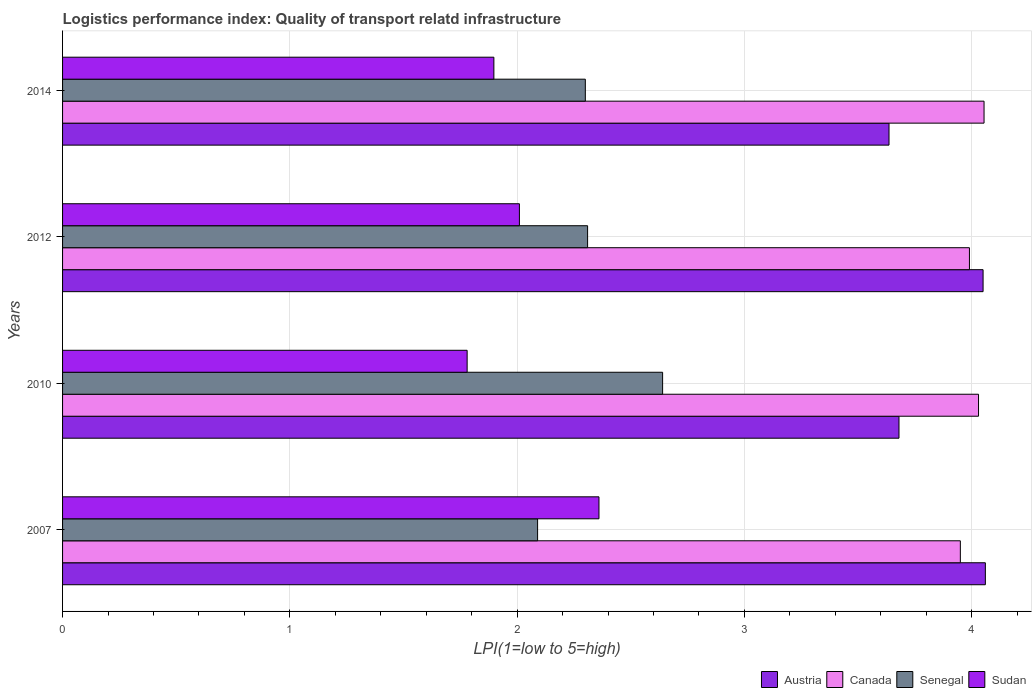How many different coloured bars are there?
Ensure brevity in your answer.  4. Are the number of bars per tick equal to the number of legend labels?
Provide a succinct answer. Yes. How many bars are there on the 4th tick from the top?
Keep it short and to the point. 4. How many bars are there on the 4th tick from the bottom?
Make the answer very short. 4. What is the logistics performance index in Canada in 2012?
Offer a very short reply. 3.99. Across all years, what is the maximum logistics performance index in Senegal?
Make the answer very short. 2.64. Across all years, what is the minimum logistics performance index in Austria?
Provide a short and direct response. 3.64. In which year was the logistics performance index in Austria minimum?
Your answer should be compact. 2014. What is the total logistics performance index in Canada in the graph?
Provide a succinct answer. 16.02. What is the difference between the logistics performance index in Canada in 2010 and that in 2014?
Make the answer very short. -0.02. What is the difference between the logistics performance index in Senegal in 2014 and the logistics performance index in Canada in 2007?
Ensure brevity in your answer.  -1.65. What is the average logistics performance index in Austria per year?
Your answer should be compact. 3.86. In the year 2007, what is the difference between the logistics performance index in Canada and logistics performance index in Senegal?
Offer a terse response. 1.86. In how many years, is the logistics performance index in Canada greater than 2.6 ?
Your answer should be compact. 4. What is the ratio of the logistics performance index in Sudan in 2007 to that in 2014?
Your response must be concise. 1.24. What is the difference between the highest and the second highest logistics performance index in Sudan?
Ensure brevity in your answer.  0.35. What is the difference between the highest and the lowest logistics performance index in Sudan?
Provide a succinct answer. 0.58. In how many years, is the logistics performance index in Sudan greater than the average logistics performance index in Sudan taken over all years?
Offer a very short reply. 1. Is the sum of the logistics performance index in Austria in 2007 and 2014 greater than the maximum logistics performance index in Sudan across all years?
Ensure brevity in your answer.  Yes. Is it the case that in every year, the sum of the logistics performance index in Senegal and logistics performance index in Canada is greater than the sum of logistics performance index in Sudan and logistics performance index in Austria?
Your answer should be very brief. Yes. What does the 2nd bar from the top in 2014 represents?
Ensure brevity in your answer.  Senegal. Is it the case that in every year, the sum of the logistics performance index in Austria and logistics performance index in Canada is greater than the logistics performance index in Senegal?
Make the answer very short. Yes. What is the difference between two consecutive major ticks on the X-axis?
Provide a succinct answer. 1. Does the graph contain grids?
Your answer should be very brief. Yes. How many legend labels are there?
Provide a short and direct response. 4. What is the title of the graph?
Your answer should be very brief. Logistics performance index: Quality of transport relatd infrastructure. Does "Pacific island small states" appear as one of the legend labels in the graph?
Your answer should be very brief. No. What is the label or title of the X-axis?
Make the answer very short. LPI(1=low to 5=high). What is the label or title of the Y-axis?
Make the answer very short. Years. What is the LPI(1=low to 5=high) of Austria in 2007?
Make the answer very short. 4.06. What is the LPI(1=low to 5=high) of Canada in 2007?
Offer a terse response. 3.95. What is the LPI(1=low to 5=high) of Senegal in 2007?
Offer a very short reply. 2.09. What is the LPI(1=low to 5=high) in Sudan in 2007?
Provide a succinct answer. 2.36. What is the LPI(1=low to 5=high) of Austria in 2010?
Your answer should be compact. 3.68. What is the LPI(1=low to 5=high) in Canada in 2010?
Your response must be concise. 4.03. What is the LPI(1=low to 5=high) in Senegal in 2010?
Keep it short and to the point. 2.64. What is the LPI(1=low to 5=high) of Sudan in 2010?
Keep it short and to the point. 1.78. What is the LPI(1=low to 5=high) in Austria in 2012?
Offer a terse response. 4.05. What is the LPI(1=low to 5=high) in Canada in 2012?
Make the answer very short. 3.99. What is the LPI(1=low to 5=high) in Senegal in 2012?
Ensure brevity in your answer.  2.31. What is the LPI(1=low to 5=high) of Sudan in 2012?
Provide a succinct answer. 2.01. What is the LPI(1=low to 5=high) of Austria in 2014?
Keep it short and to the point. 3.64. What is the LPI(1=low to 5=high) of Canada in 2014?
Your response must be concise. 4.05. What is the LPI(1=low to 5=high) of Sudan in 2014?
Make the answer very short. 1.9. Across all years, what is the maximum LPI(1=low to 5=high) of Austria?
Offer a terse response. 4.06. Across all years, what is the maximum LPI(1=low to 5=high) of Canada?
Your response must be concise. 4.05. Across all years, what is the maximum LPI(1=low to 5=high) of Senegal?
Your response must be concise. 2.64. Across all years, what is the maximum LPI(1=low to 5=high) in Sudan?
Your answer should be very brief. 2.36. Across all years, what is the minimum LPI(1=low to 5=high) of Austria?
Your answer should be compact. 3.64. Across all years, what is the minimum LPI(1=low to 5=high) in Canada?
Your answer should be very brief. 3.95. Across all years, what is the minimum LPI(1=low to 5=high) of Senegal?
Your response must be concise. 2.09. Across all years, what is the minimum LPI(1=low to 5=high) in Sudan?
Provide a succinct answer. 1.78. What is the total LPI(1=low to 5=high) of Austria in the graph?
Your answer should be compact. 15.43. What is the total LPI(1=low to 5=high) in Canada in the graph?
Provide a short and direct response. 16.02. What is the total LPI(1=low to 5=high) in Senegal in the graph?
Provide a succinct answer. 9.34. What is the total LPI(1=low to 5=high) in Sudan in the graph?
Provide a short and direct response. 8.05. What is the difference between the LPI(1=low to 5=high) of Austria in 2007 and that in 2010?
Ensure brevity in your answer.  0.38. What is the difference between the LPI(1=low to 5=high) of Canada in 2007 and that in 2010?
Offer a terse response. -0.08. What is the difference between the LPI(1=low to 5=high) in Senegal in 2007 and that in 2010?
Offer a terse response. -0.55. What is the difference between the LPI(1=low to 5=high) in Sudan in 2007 and that in 2010?
Provide a short and direct response. 0.58. What is the difference between the LPI(1=low to 5=high) in Austria in 2007 and that in 2012?
Your response must be concise. 0.01. What is the difference between the LPI(1=low to 5=high) of Canada in 2007 and that in 2012?
Your response must be concise. -0.04. What is the difference between the LPI(1=low to 5=high) in Senegal in 2007 and that in 2012?
Ensure brevity in your answer.  -0.22. What is the difference between the LPI(1=low to 5=high) of Sudan in 2007 and that in 2012?
Give a very brief answer. 0.35. What is the difference between the LPI(1=low to 5=high) in Austria in 2007 and that in 2014?
Keep it short and to the point. 0.42. What is the difference between the LPI(1=low to 5=high) in Canada in 2007 and that in 2014?
Provide a short and direct response. -0.1. What is the difference between the LPI(1=low to 5=high) of Senegal in 2007 and that in 2014?
Provide a short and direct response. -0.21. What is the difference between the LPI(1=low to 5=high) of Sudan in 2007 and that in 2014?
Ensure brevity in your answer.  0.46. What is the difference between the LPI(1=low to 5=high) of Austria in 2010 and that in 2012?
Provide a succinct answer. -0.37. What is the difference between the LPI(1=low to 5=high) of Canada in 2010 and that in 2012?
Keep it short and to the point. 0.04. What is the difference between the LPI(1=low to 5=high) in Senegal in 2010 and that in 2012?
Provide a succinct answer. 0.33. What is the difference between the LPI(1=low to 5=high) of Sudan in 2010 and that in 2012?
Your answer should be very brief. -0.23. What is the difference between the LPI(1=low to 5=high) in Austria in 2010 and that in 2014?
Give a very brief answer. 0.04. What is the difference between the LPI(1=low to 5=high) of Canada in 2010 and that in 2014?
Ensure brevity in your answer.  -0.02. What is the difference between the LPI(1=low to 5=high) of Senegal in 2010 and that in 2014?
Offer a very short reply. 0.34. What is the difference between the LPI(1=low to 5=high) in Sudan in 2010 and that in 2014?
Provide a succinct answer. -0.12. What is the difference between the LPI(1=low to 5=high) in Austria in 2012 and that in 2014?
Provide a succinct answer. 0.41. What is the difference between the LPI(1=low to 5=high) of Canada in 2012 and that in 2014?
Your response must be concise. -0.06. What is the difference between the LPI(1=low to 5=high) of Senegal in 2012 and that in 2014?
Offer a terse response. 0.01. What is the difference between the LPI(1=low to 5=high) in Sudan in 2012 and that in 2014?
Keep it short and to the point. 0.11. What is the difference between the LPI(1=low to 5=high) of Austria in 2007 and the LPI(1=low to 5=high) of Senegal in 2010?
Provide a short and direct response. 1.42. What is the difference between the LPI(1=low to 5=high) of Austria in 2007 and the LPI(1=low to 5=high) of Sudan in 2010?
Provide a succinct answer. 2.28. What is the difference between the LPI(1=low to 5=high) of Canada in 2007 and the LPI(1=low to 5=high) of Senegal in 2010?
Ensure brevity in your answer.  1.31. What is the difference between the LPI(1=low to 5=high) of Canada in 2007 and the LPI(1=low to 5=high) of Sudan in 2010?
Your answer should be very brief. 2.17. What is the difference between the LPI(1=low to 5=high) in Senegal in 2007 and the LPI(1=low to 5=high) in Sudan in 2010?
Offer a terse response. 0.31. What is the difference between the LPI(1=low to 5=high) in Austria in 2007 and the LPI(1=low to 5=high) in Canada in 2012?
Your answer should be very brief. 0.07. What is the difference between the LPI(1=low to 5=high) of Austria in 2007 and the LPI(1=low to 5=high) of Sudan in 2012?
Make the answer very short. 2.05. What is the difference between the LPI(1=low to 5=high) in Canada in 2007 and the LPI(1=low to 5=high) in Senegal in 2012?
Provide a succinct answer. 1.64. What is the difference between the LPI(1=low to 5=high) in Canada in 2007 and the LPI(1=low to 5=high) in Sudan in 2012?
Your answer should be compact. 1.94. What is the difference between the LPI(1=low to 5=high) in Austria in 2007 and the LPI(1=low to 5=high) in Canada in 2014?
Give a very brief answer. 0.01. What is the difference between the LPI(1=low to 5=high) in Austria in 2007 and the LPI(1=low to 5=high) in Senegal in 2014?
Your answer should be compact. 1.76. What is the difference between the LPI(1=low to 5=high) of Austria in 2007 and the LPI(1=low to 5=high) of Sudan in 2014?
Keep it short and to the point. 2.16. What is the difference between the LPI(1=low to 5=high) in Canada in 2007 and the LPI(1=low to 5=high) in Senegal in 2014?
Offer a very short reply. 1.65. What is the difference between the LPI(1=low to 5=high) in Canada in 2007 and the LPI(1=low to 5=high) in Sudan in 2014?
Give a very brief answer. 2.05. What is the difference between the LPI(1=low to 5=high) in Senegal in 2007 and the LPI(1=low to 5=high) in Sudan in 2014?
Your answer should be compact. 0.19. What is the difference between the LPI(1=low to 5=high) of Austria in 2010 and the LPI(1=low to 5=high) of Canada in 2012?
Ensure brevity in your answer.  -0.31. What is the difference between the LPI(1=low to 5=high) of Austria in 2010 and the LPI(1=low to 5=high) of Senegal in 2012?
Ensure brevity in your answer.  1.37. What is the difference between the LPI(1=low to 5=high) of Austria in 2010 and the LPI(1=low to 5=high) of Sudan in 2012?
Make the answer very short. 1.67. What is the difference between the LPI(1=low to 5=high) of Canada in 2010 and the LPI(1=low to 5=high) of Senegal in 2012?
Keep it short and to the point. 1.72. What is the difference between the LPI(1=low to 5=high) of Canada in 2010 and the LPI(1=low to 5=high) of Sudan in 2012?
Offer a very short reply. 2.02. What is the difference between the LPI(1=low to 5=high) of Senegal in 2010 and the LPI(1=low to 5=high) of Sudan in 2012?
Give a very brief answer. 0.63. What is the difference between the LPI(1=low to 5=high) of Austria in 2010 and the LPI(1=low to 5=high) of Canada in 2014?
Make the answer very short. -0.37. What is the difference between the LPI(1=low to 5=high) of Austria in 2010 and the LPI(1=low to 5=high) of Senegal in 2014?
Offer a terse response. 1.38. What is the difference between the LPI(1=low to 5=high) of Austria in 2010 and the LPI(1=low to 5=high) of Sudan in 2014?
Keep it short and to the point. 1.78. What is the difference between the LPI(1=low to 5=high) in Canada in 2010 and the LPI(1=low to 5=high) in Senegal in 2014?
Offer a terse response. 1.73. What is the difference between the LPI(1=low to 5=high) of Canada in 2010 and the LPI(1=low to 5=high) of Sudan in 2014?
Offer a terse response. 2.13. What is the difference between the LPI(1=low to 5=high) of Senegal in 2010 and the LPI(1=low to 5=high) of Sudan in 2014?
Ensure brevity in your answer.  0.74. What is the difference between the LPI(1=low to 5=high) of Austria in 2012 and the LPI(1=low to 5=high) of Canada in 2014?
Your response must be concise. -0. What is the difference between the LPI(1=low to 5=high) in Austria in 2012 and the LPI(1=low to 5=high) in Senegal in 2014?
Your answer should be compact. 1.75. What is the difference between the LPI(1=low to 5=high) of Austria in 2012 and the LPI(1=low to 5=high) of Sudan in 2014?
Offer a terse response. 2.15. What is the difference between the LPI(1=low to 5=high) in Canada in 2012 and the LPI(1=low to 5=high) in Senegal in 2014?
Keep it short and to the point. 1.69. What is the difference between the LPI(1=low to 5=high) in Canada in 2012 and the LPI(1=low to 5=high) in Sudan in 2014?
Keep it short and to the point. 2.09. What is the difference between the LPI(1=low to 5=high) of Senegal in 2012 and the LPI(1=low to 5=high) of Sudan in 2014?
Give a very brief answer. 0.41. What is the average LPI(1=low to 5=high) in Austria per year?
Give a very brief answer. 3.86. What is the average LPI(1=low to 5=high) of Canada per year?
Offer a terse response. 4.01. What is the average LPI(1=low to 5=high) in Senegal per year?
Your answer should be very brief. 2.33. What is the average LPI(1=low to 5=high) in Sudan per year?
Give a very brief answer. 2.01. In the year 2007, what is the difference between the LPI(1=low to 5=high) in Austria and LPI(1=low to 5=high) in Canada?
Your answer should be very brief. 0.11. In the year 2007, what is the difference between the LPI(1=low to 5=high) of Austria and LPI(1=low to 5=high) of Senegal?
Provide a succinct answer. 1.97. In the year 2007, what is the difference between the LPI(1=low to 5=high) in Canada and LPI(1=low to 5=high) in Senegal?
Your answer should be compact. 1.86. In the year 2007, what is the difference between the LPI(1=low to 5=high) of Canada and LPI(1=low to 5=high) of Sudan?
Provide a succinct answer. 1.59. In the year 2007, what is the difference between the LPI(1=low to 5=high) of Senegal and LPI(1=low to 5=high) of Sudan?
Your answer should be compact. -0.27. In the year 2010, what is the difference between the LPI(1=low to 5=high) of Austria and LPI(1=low to 5=high) of Canada?
Your response must be concise. -0.35. In the year 2010, what is the difference between the LPI(1=low to 5=high) of Canada and LPI(1=low to 5=high) of Senegal?
Offer a terse response. 1.39. In the year 2010, what is the difference between the LPI(1=low to 5=high) in Canada and LPI(1=low to 5=high) in Sudan?
Provide a short and direct response. 2.25. In the year 2010, what is the difference between the LPI(1=low to 5=high) in Senegal and LPI(1=low to 5=high) in Sudan?
Offer a terse response. 0.86. In the year 2012, what is the difference between the LPI(1=low to 5=high) of Austria and LPI(1=low to 5=high) of Canada?
Ensure brevity in your answer.  0.06. In the year 2012, what is the difference between the LPI(1=low to 5=high) of Austria and LPI(1=low to 5=high) of Senegal?
Ensure brevity in your answer.  1.74. In the year 2012, what is the difference between the LPI(1=low to 5=high) in Austria and LPI(1=low to 5=high) in Sudan?
Provide a short and direct response. 2.04. In the year 2012, what is the difference between the LPI(1=low to 5=high) in Canada and LPI(1=low to 5=high) in Senegal?
Offer a terse response. 1.68. In the year 2012, what is the difference between the LPI(1=low to 5=high) of Canada and LPI(1=low to 5=high) of Sudan?
Your answer should be very brief. 1.98. In the year 2014, what is the difference between the LPI(1=low to 5=high) of Austria and LPI(1=low to 5=high) of Canada?
Provide a short and direct response. -0.42. In the year 2014, what is the difference between the LPI(1=low to 5=high) in Austria and LPI(1=low to 5=high) in Senegal?
Offer a terse response. 1.34. In the year 2014, what is the difference between the LPI(1=low to 5=high) of Austria and LPI(1=low to 5=high) of Sudan?
Your answer should be compact. 1.74. In the year 2014, what is the difference between the LPI(1=low to 5=high) of Canada and LPI(1=low to 5=high) of Senegal?
Keep it short and to the point. 1.75. In the year 2014, what is the difference between the LPI(1=low to 5=high) in Canada and LPI(1=low to 5=high) in Sudan?
Provide a short and direct response. 2.16. In the year 2014, what is the difference between the LPI(1=low to 5=high) in Senegal and LPI(1=low to 5=high) in Sudan?
Your answer should be compact. 0.4. What is the ratio of the LPI(1=low to 5=high) in Austria in 2007 to that in 2010?
Keep it short and to the point. 1.1. What is the ratio of the LPI(1=low to 5=high) of Canada in 2007 to that in 2010?
Keep it short and to the point. 0.98. What is the ratio of the LPI(1=low to 5=high) in Senegal in 2007 to that in 2010?
Make the answer very short. 0.79. What is the ratio of the LPI(1=low to 5=high) of Sudan in 2007 to that in 2010?
Give a very brief answer. 1.33. What is the ratio of the LPI(1=low to 5=high) in Austria in 2007 to that in 2012?
Offer a very short reply. 1. What is the ratio of the LPI(1=low to 5=high) in Senegal in 2007 to that in 2012?
Your answer should be very brief. 0.9. What is the ratio of the LPI(1=low to 5=high) in Sudan in 2007 to that in 2012?
Ensure brevity in your answer.  1.17. What is the ratio of the LPI(1=low to 5=high) in Austria in 2007 to that in 2014?
Keep it short and to the point. 1.12. What is the ratio of the LPI(1=low to 5=high) in Canada in 2007 to that in 2014?
Your answer should be compact. 0.97. What is the ratio of the LPI(1=low to 5=high) in Senegal in 2007 to that in 2014?
Your answer should be compact. 0.91. What is the ratio of the LPI(1=low to 5=high) of Sudan in 2007 to that in 2014?
Keep it short and to the point. 1.24. What is the ratio of the LPI(1=low to 5=high) in Austria in 2010 to that in 2012?
Offer a terse response. 0.91. What is the ratio of the LPI(1=low to 5=high) in Sudan in 2010 to that in 2012?
Give a very brief answer. 0.89. What is the ratio of the LPI(1=low to 5=high) in Austria in 2010 to that in 2014?
Ensure brevity in your answer.  1.01. What is the ratio of the LPI(1=low to 5=high) of Senegal in 2010 to that in 2014?
Keep it short and to the point. 1.15. What is the ratio of the LPI(1=low to 5=high) in Sudan in 2010 to that in 2014?
Your answer should be very brief. 0.94. What is the ratio of the LPI(1=low to 5=high) of Austria in 2012 to that in 2014?
Provide a short and direct response. 1.11. What is the ratio of the LPI(1=low to 5=high) of Canada in 2012 to that in 2014?
Your answer should be very brief. 0.98. What is the ratio of the LPI(1=low to 5=high) in Sudan in 2012 to that in 2014?
Your answer should be very brief. 1.06. What is the difference between the highest and the second highest LPI(1=low to 5=high) of Austria?
Provide a succinct answer. 0.01. What is the difference between the highest and the second highest LPI(1=low to 5=high) in Canada?
Ensure brevity in your answer.  0.02. What is the difference between the highest and the second highest LPI(1=low to 5=high) in Senegal?
Give a very brief answer. 0.33. What is the difference between the highest and the second highest LPI(1=low to 5=high) in Sudan?
Your response must be concise. 0.35. What is the difference between the highest and the lowest LPI(1=low to 5=high) in Austria?
Your answer should be compact. 0.42. What is the difference between the highest and the lowest LPI(1=low to 5=high) in Canada?
Your answer should be compact. 0.1. What is the difference between the highest and the lowest LPI(1=low to 5=high) of Senegal?
Give a very brief answer. 0.55. What is the difference between the highest and the lowest LPI(1=low to 5=high) of Sudan?
Keep it short and to the point. 0.58. 